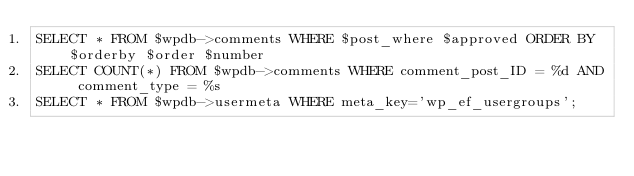<code> <loc_0><loc_0><loc_500><loc_500><_SQL_>SELECT * FROM $wpdb->comments WHERE $post_where $approved ORDER BY $orderby $order $number
SELECT COUNT(*) FROM $wpdb->comments WHERE comment_post_ID = %d AND comment_type = %s
SELECT * FROM $wpdb->usermeta WHERE meta_key='wp_ef_usergroups';
</code> 